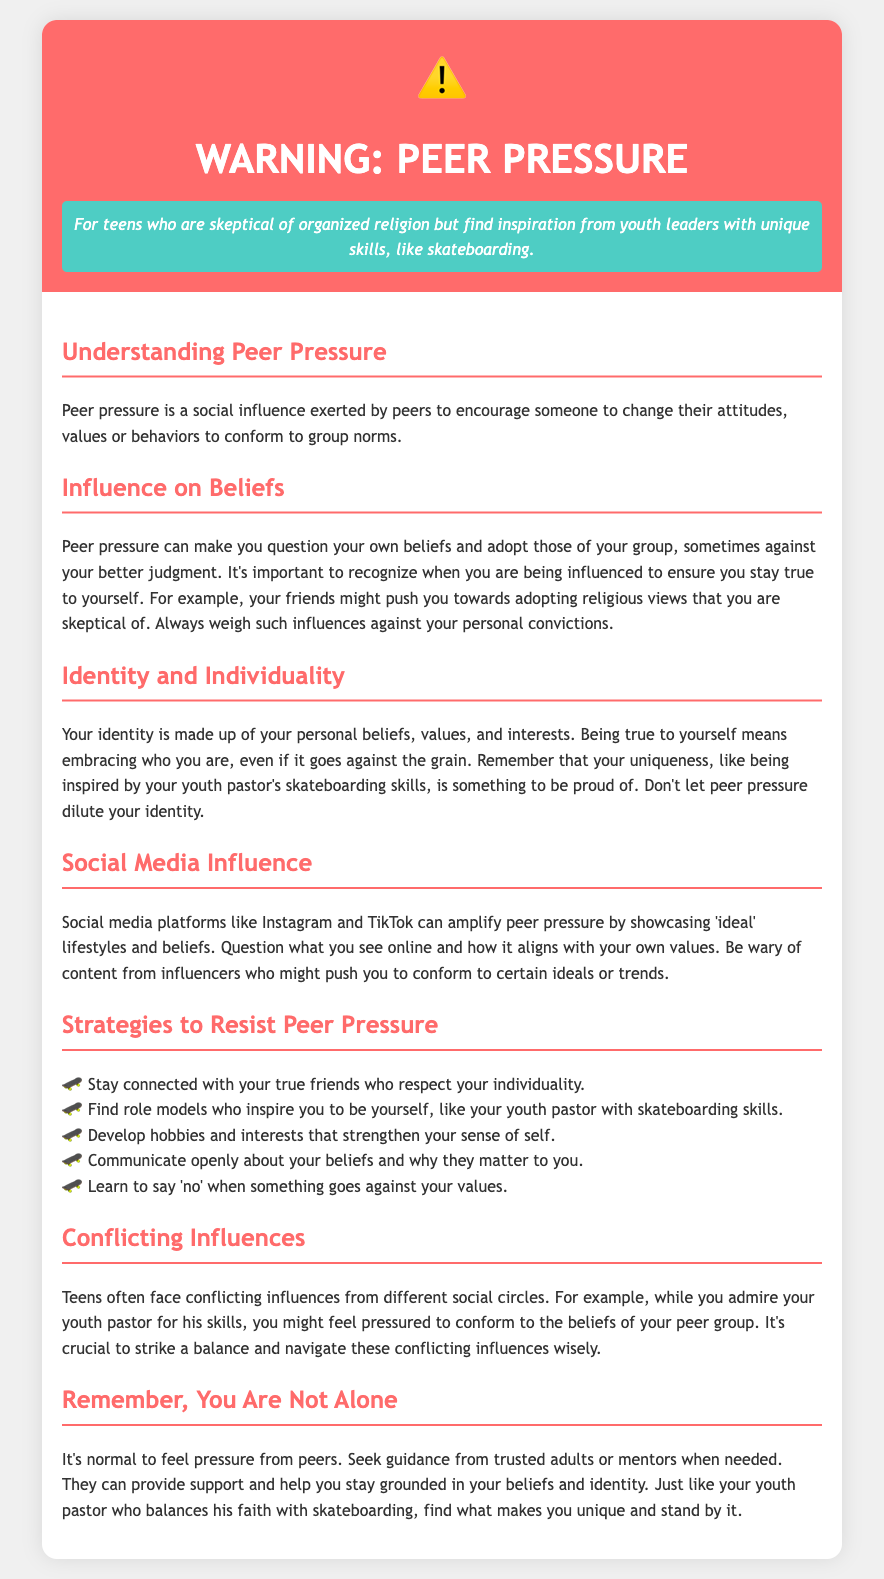What is peer pressure? Peer pressure is defined in the document as a social influence exerted by peers to encourage someone to change their attitudes, values or behaviors to conform to group norms.
Answer: A social influence What can peer pressure make you question? The document states that peer pressure can make you question your own beliefs and adopt those of your group.
Answer: Your own beliefs What should you stay connected with according to the strategies? The document suggests staying connected with your true friends who respect your individuality.
Answer: True friends What is one example of conflicting influences mentioned? An example given in the document is admiring your youth pastor for his skills while feeling pressured to conform to the beliefs of your peer group.
Answer: Youth pastor skills Which social media platforms are mentioned as amplifying peer pressure? The document mentions Instagram and TikTok as platforms that can amplify peer pressure.
Answer: Instagram and TikTok What is emphasized as important to staying true to yourself? The document emphasizes that it is important to recognize when you are being influenced to ensure you stay true to yourself.
Answer: Recognizing influence What should you learn to say when something goes against your values? The document states that you should learn to say 'no' when something goes against your values.
Answer: No What can trusted adults or mentors provide according to the document? The document states that trusted adults or mentors can provide support and help you stay grounded in your beliefs and identity.
Answer: Support 